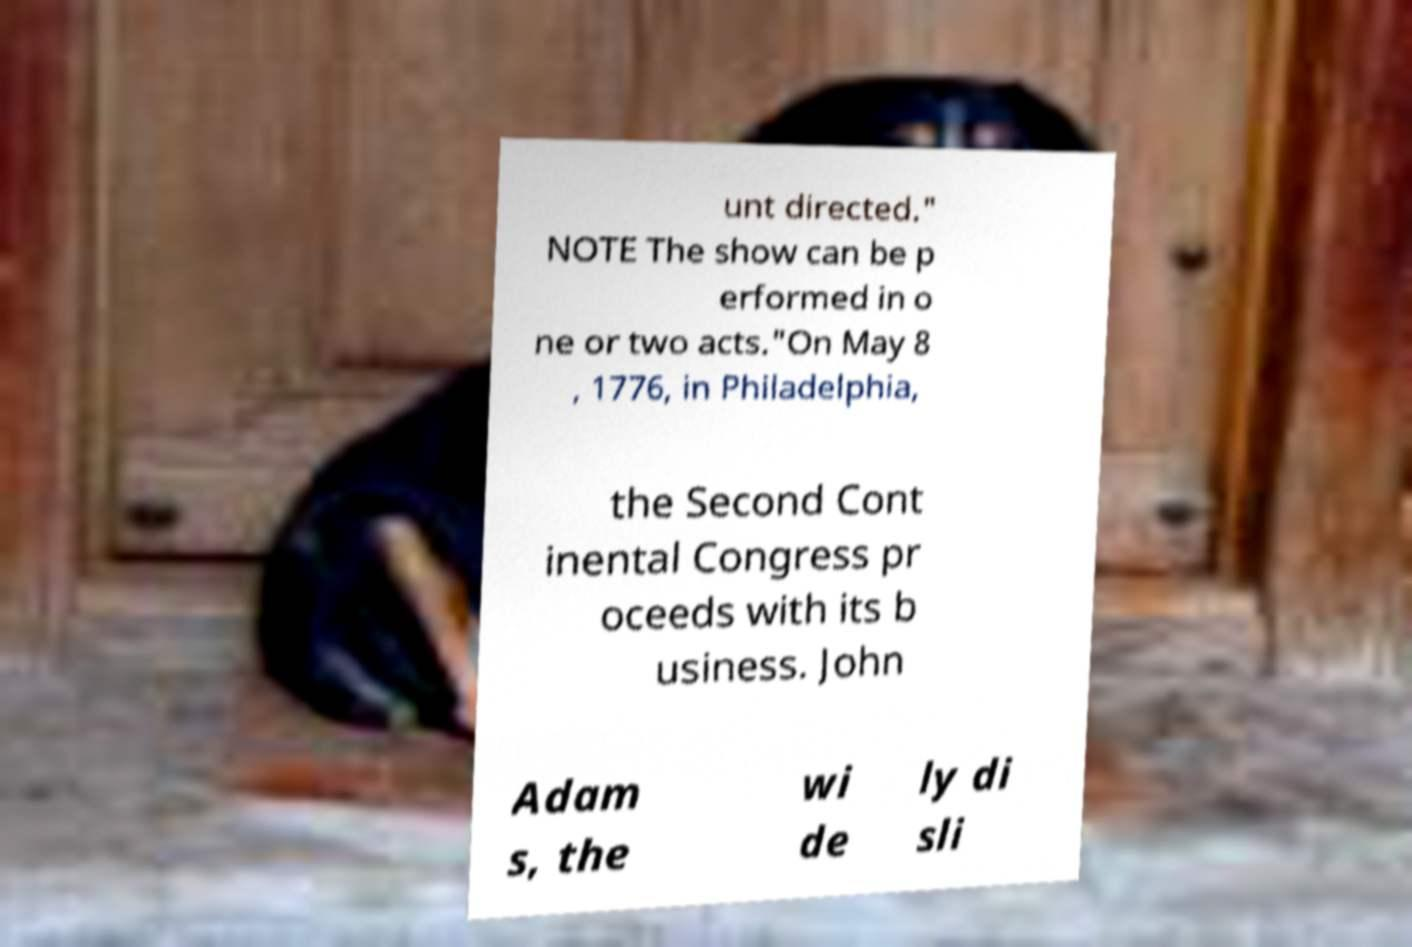Please read and relay the text visible in this image. What does it say? unt directed." NOTE The show can be p erformed in o ne or two acts."On May 8 , 1776, in Philadelphia, the Second Cont inental Congress pr oceeds with its b usiness. John Adam s, the wi de ly di sli 